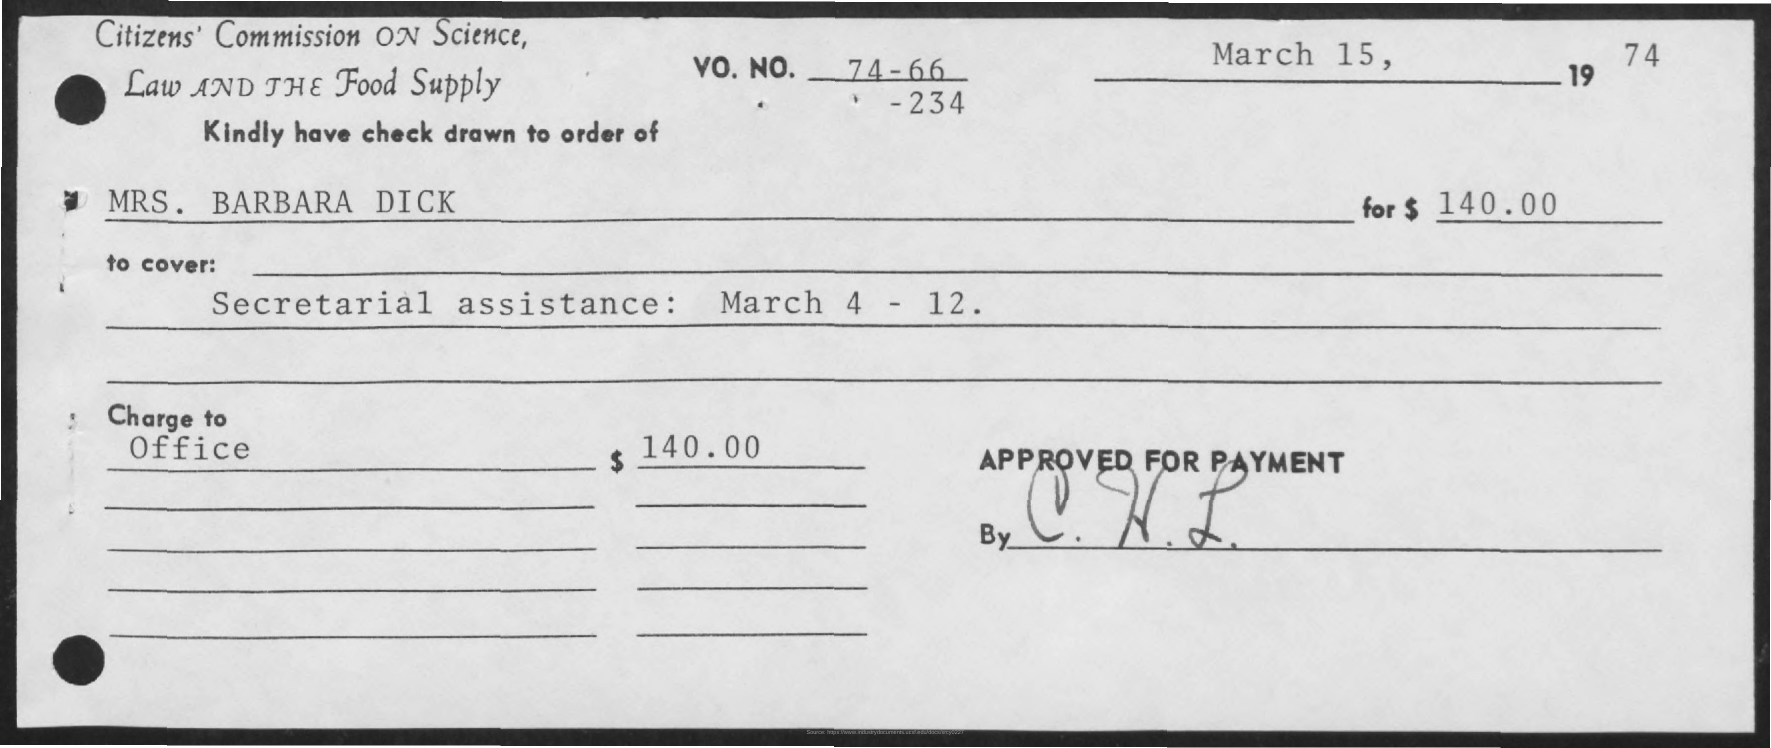What is the amount of check given?
Ensure brevity in your answer.  $140.00. In whose name, the check is issued?
Offer a very short reply. MRS. BARBARA DICK. What is the date mentioned in the check?
Your answer should be very brief. March 15, 1974. 